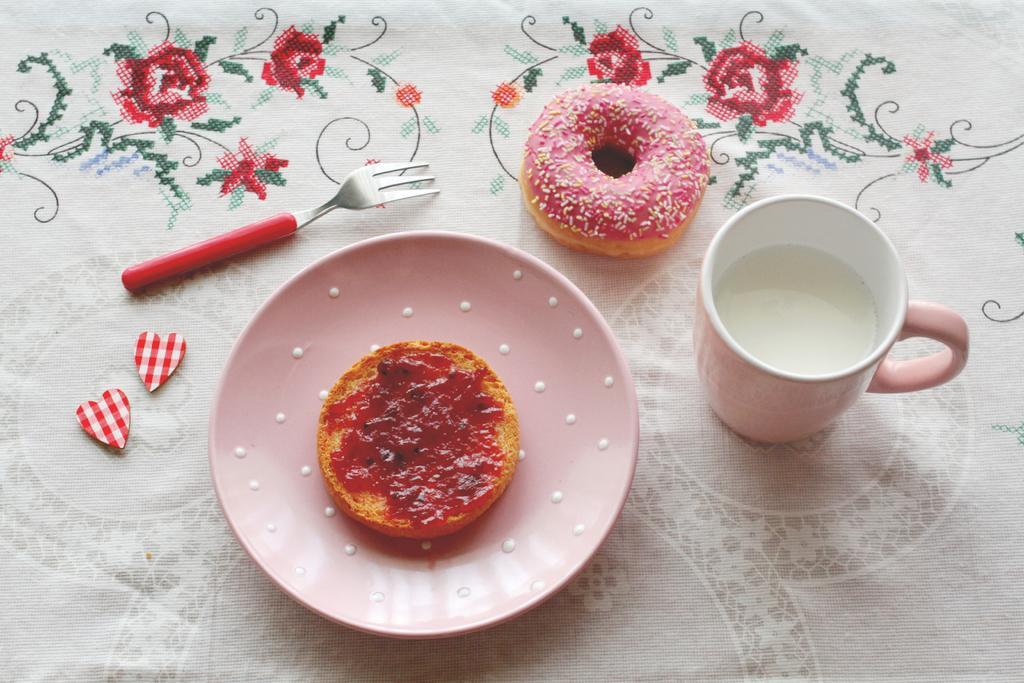In one or two sentences, can you explain what this image depicts? This is table. On the table there is a cloth, fork, doughnut, cup with milk, plate, and food. 